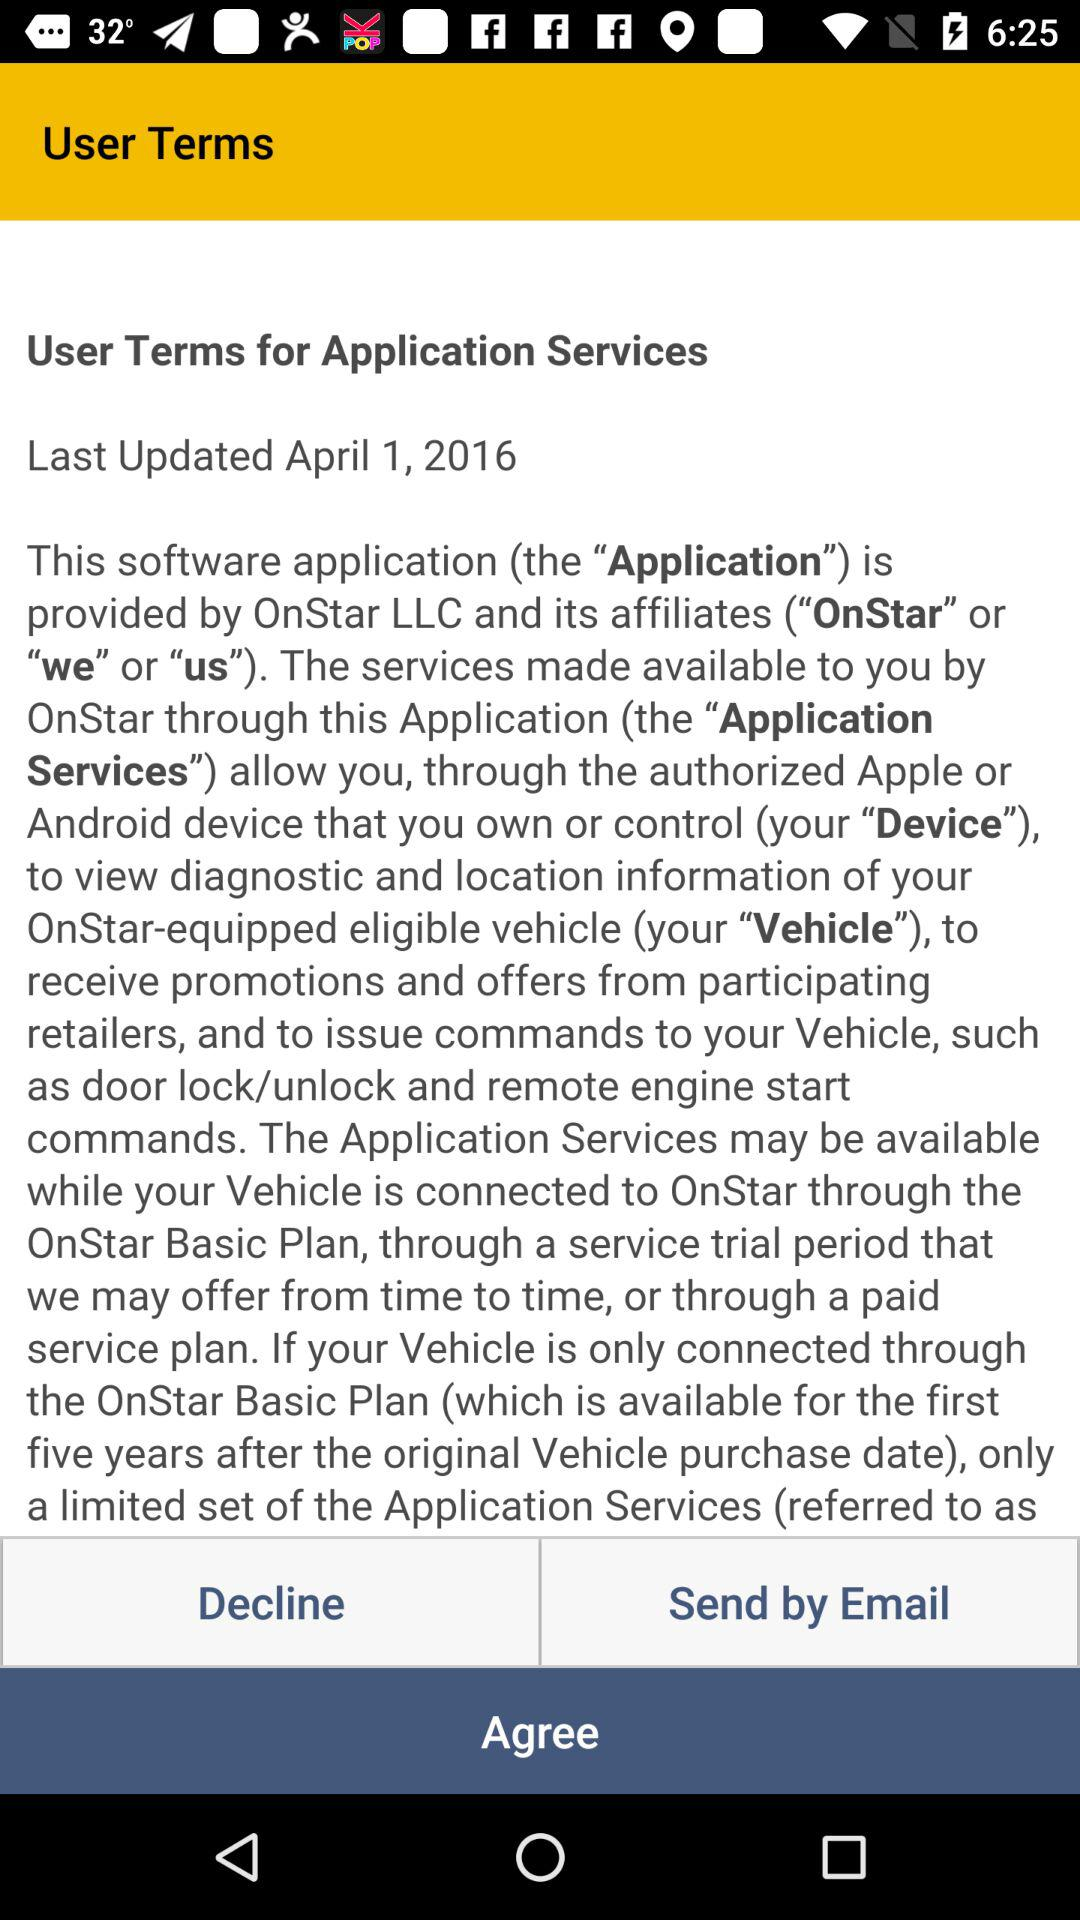When was the "User Terms for Application Services" last updated? It was last updated on April 1, 2016. 